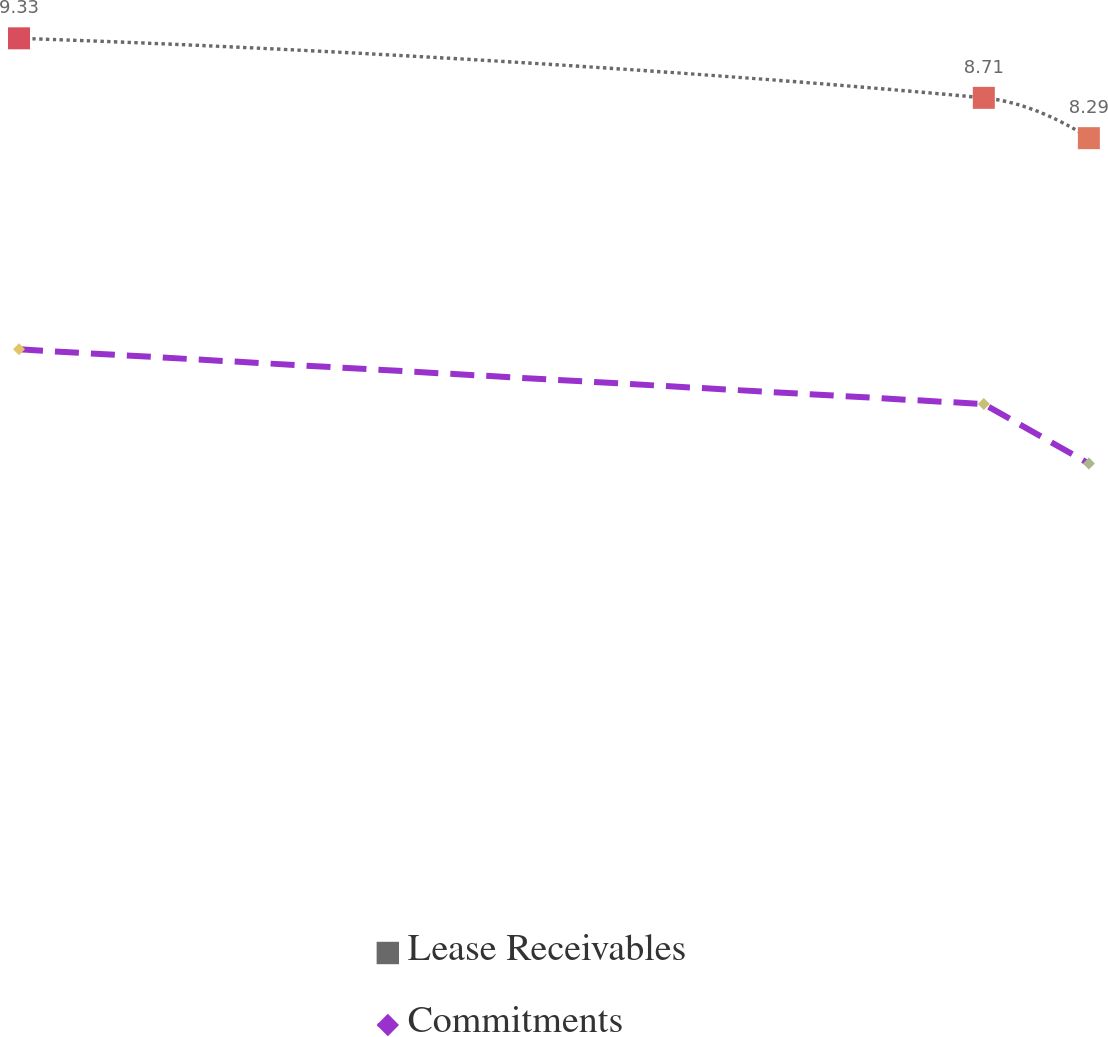<chart> <loc_0><loc_0><loc_500><loc_500><line_chart><ecel><fcel>Lease Receivables<fcel>Commitments<nl><fcel>1986.84<fcel>9.33<fcel>6.09<nl><fcel>2289.53<fcel>8.71<fcel>5.52<nl><fcel>2322.49<fcel>8.29<fcel>4.9<nl><fcel>2355.45<fcel>8.01<fcel>4.6<nl><fcel>2388.41<fcel>6.49<fcel>3.12<nl></chart> 